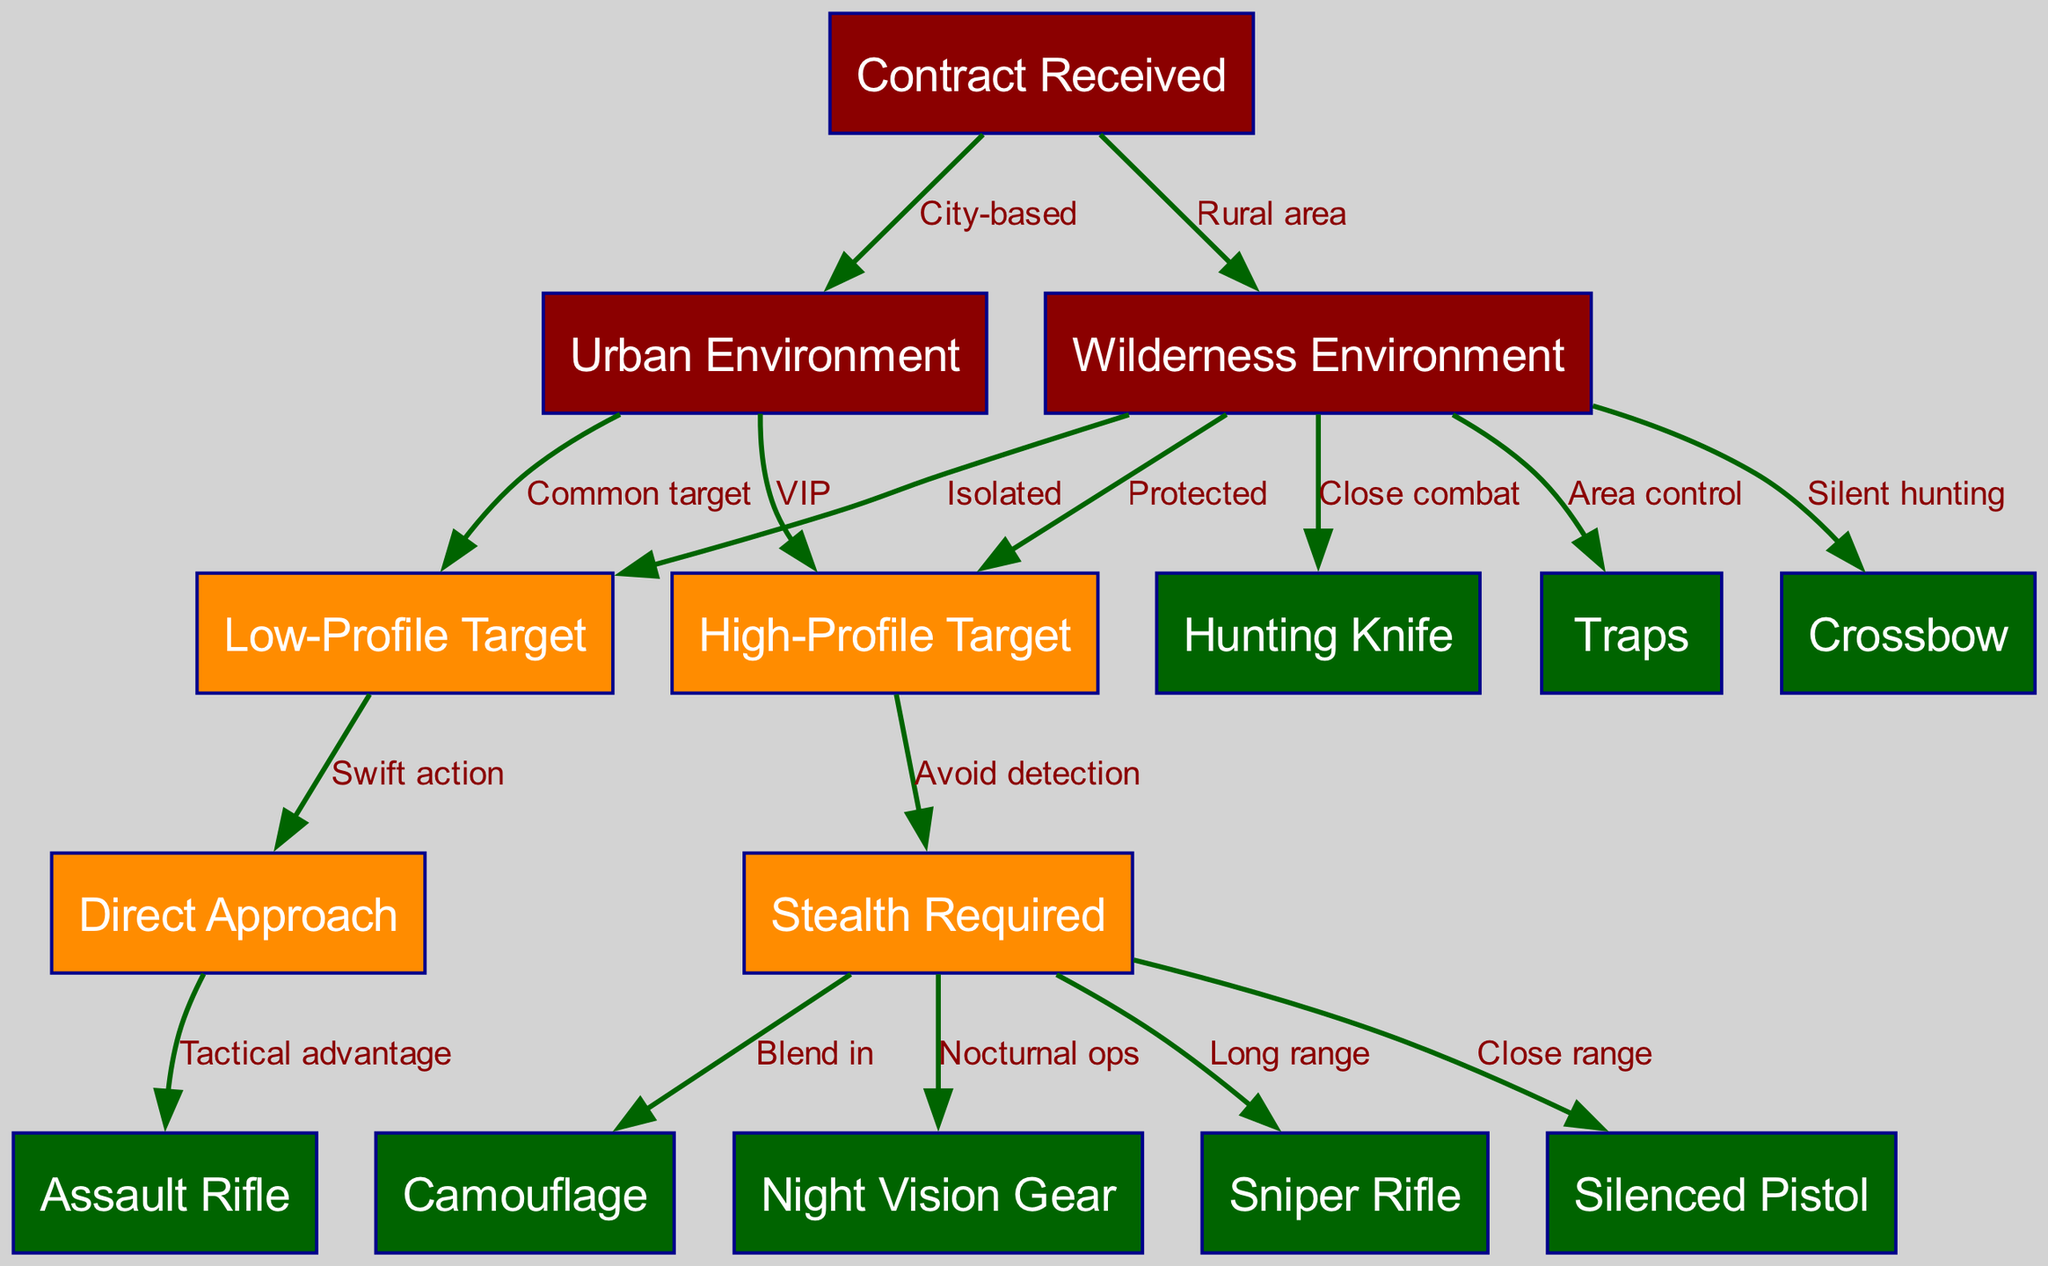What are the different environments listed in the diagram? The nodes "Urban Environment" and "Wilderness Environment" are directly connected from the "Contract Received" node, indicating the two distinct environments in which contracts may occur.
Answer: Urban Environment, Wilderness Environment How many edges are present in the diagram? The edges represent the connections between nodes, and by counting them within the provided data, there are 14 edges connecting various nodes.
Answer: 14 What type of weapon is recommended for stealth operations? From the "Stealth Required" node, two weapons are specified: "Sniper Rifle" for long range and "Silenced Pistol" for close range, making them both appropriate for stealth operations.
Answer: Sniper Rifle, Silenced Pistol Which approach is suitable for low-profile targets? The node "Low-Profile Target" leads directly to the "Direct Approach" node, indicating that swift action is recommended for these targets.
Answer: Direct Approach In a wilderness environment, what tactics are recommended for close combat? The edges from "Wilderness Environment" to "Hunting Knife" show that the hunting knife is specifically linked as a weapon suitable for close combat in this environment.
Answer: Hunting Knife How is the "High-Profile Target" characterized in terms of execution? The "High-Profile Target" node leads to "Stealth Required," illustrating that the strategy to address these targets necessitates avoidance of detection.
Answer: Avoid detection Which weapon is associated with silent hunting in the wilderness? The edge from "Wilderness Environment" directly points to "Crossbow," indicating this weapon is classified for silent hunting specifically.
Answer: Crossbow If the environment is urban and the target is high-profile, what weapon should be used in stealth? The path leads through "Urban Environment" to "High-Profile Target," and then to "Stealth Required," which allows for either a "Sniper Rifle" or "Silenced Pistol" in stealth mode.
Answer: Sniper Rifle, Silenced Pistol What is the purpose of "Traps" in the wilderness environment? The edge from "Wilderness Environment" to "Traps" suggests they are used for controlling areas and managing target encounters effectively in that environment.
Answer: Area control 